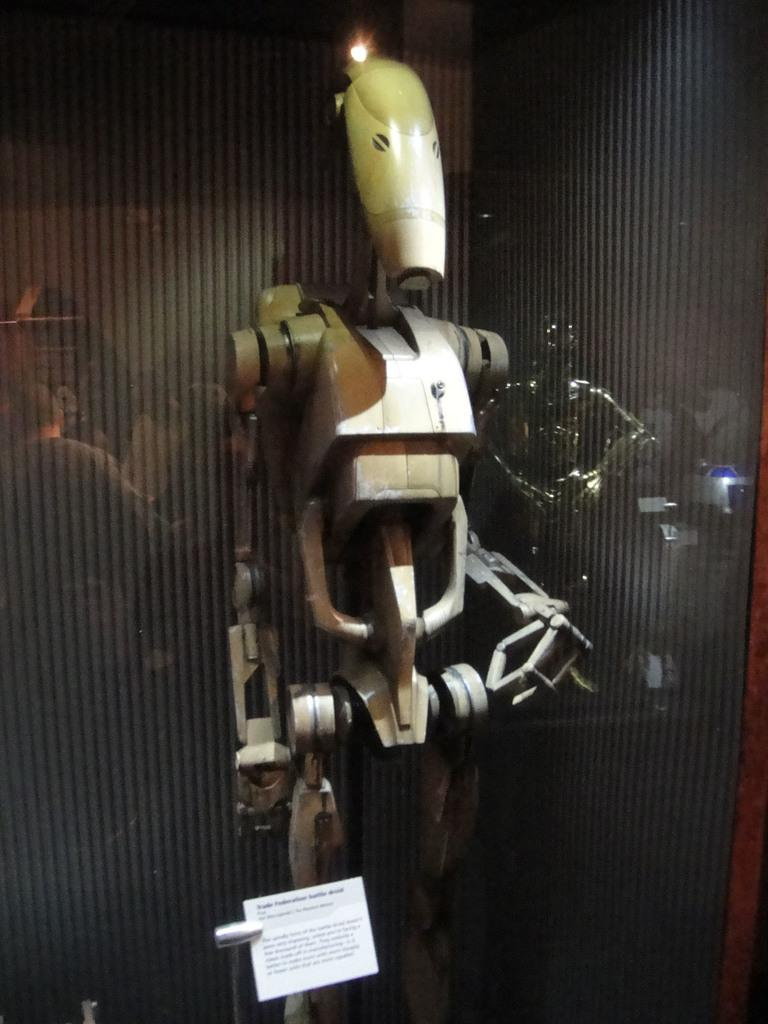What is the main subject in the center of the image? There is a robot in the center of the image. What is located at the bottom of the image? There is a board at the bottom of the image. What can be seen in the background of the image? There is a reflection of people on the glass in the background of the image. How many snails are crawling on the robot's arm in the image? There are no snails present in the image; the main subject is a robot. What is the robot using to give a thumbs-up in the image? The robot does not have a thumb or any limbs that could be used to give a thumbs-up; it is a mechanical object. 